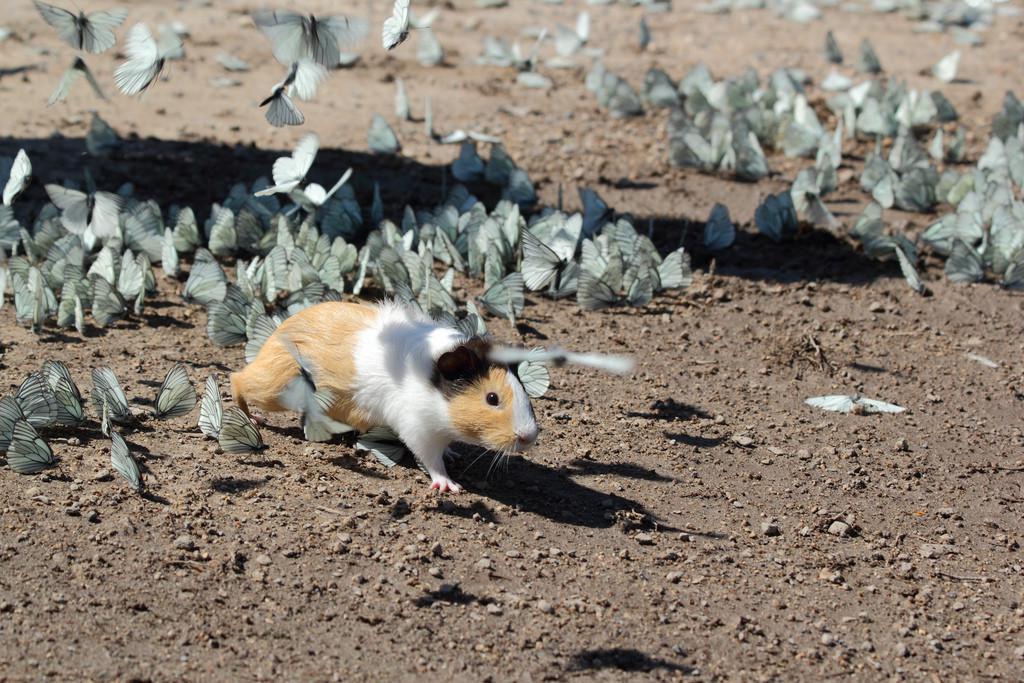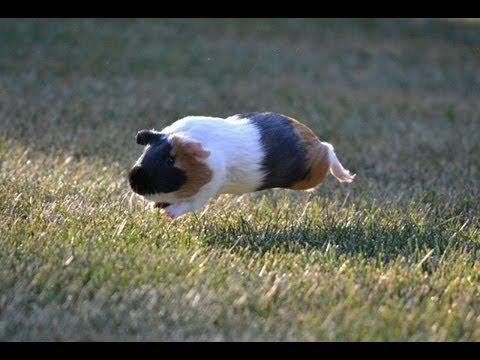The first image is the image on the left, the second image is the image on the right. For the images displayed, is the sentence "Guinea pigs are clustered around a pile of vegetables in one photo." factually correct? Answer yes or no. No. 